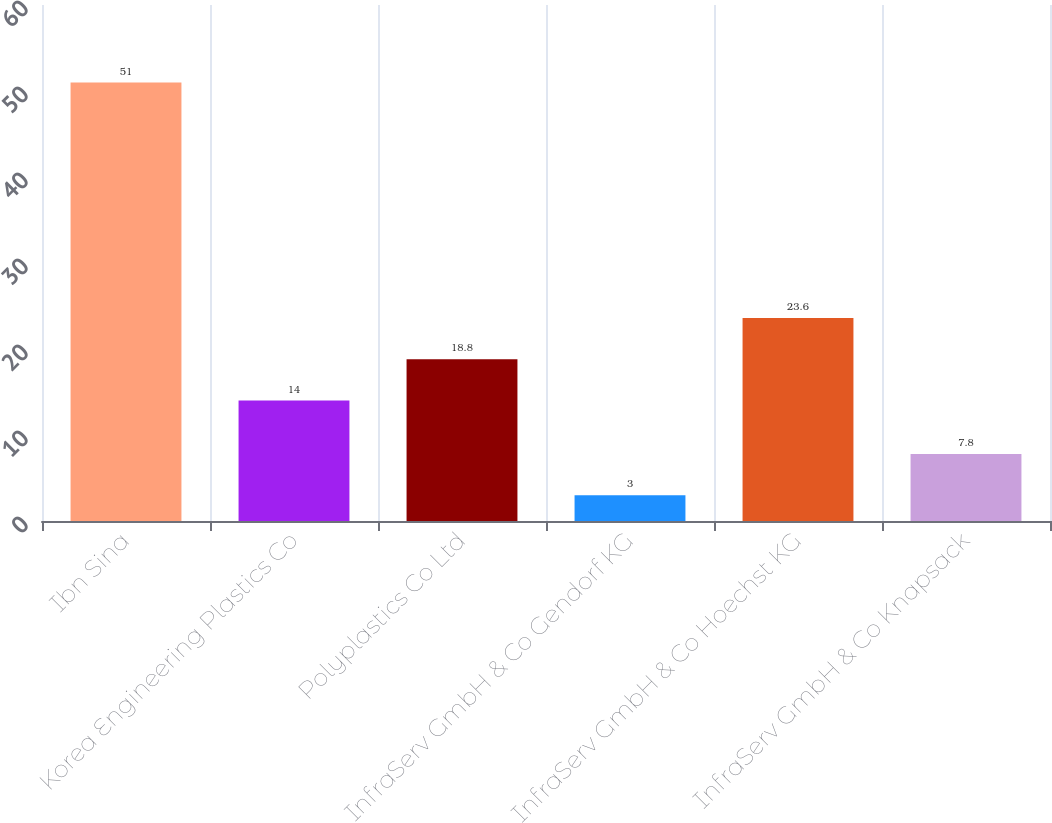Convert chart to OTSL. <chart><loc_0><loc_0><loc_500><loc_500><bar_chart><fcel>Ibn Sina<fcel>Korea Engineering Plastics Co<fcel>Polyplastics Co Ltd<fcel>InfraServ GmbH & Co Gendorf KG<fcel>InfraServ GmbH & Co Hoechst KG<fcel>InfraServ GmbH & Co Knapsack<nl><fcel>51<fcel>14<fcel>18.8<fcel>3<fcel>23.6<fcel>7.8<nl></chart> 